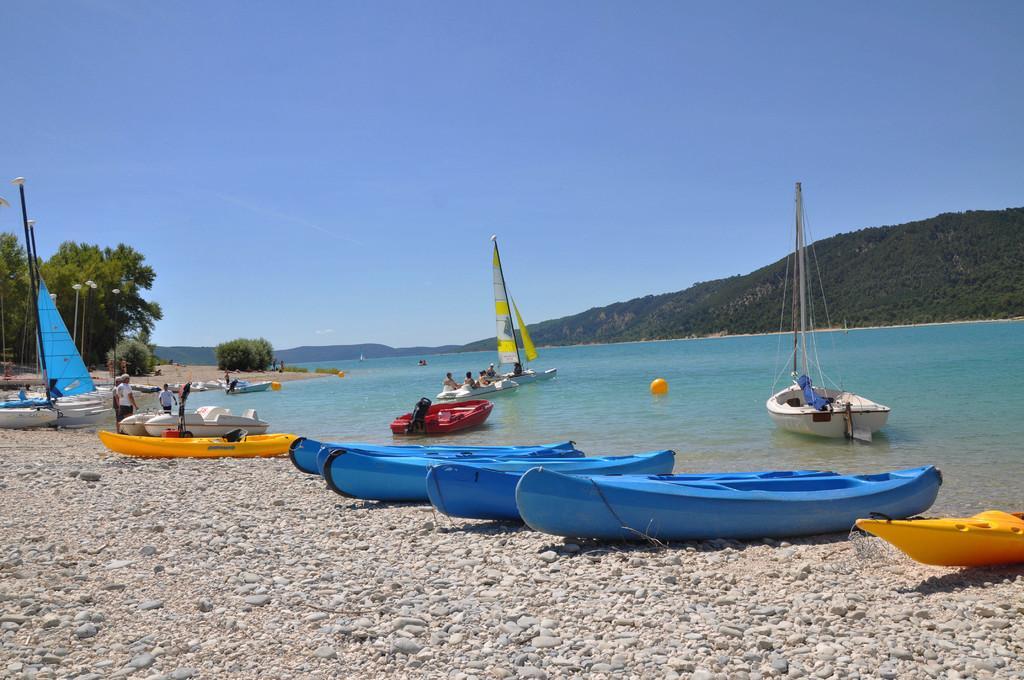Can you describe this image briefly? In this image I can see the ground, few small stones and number of boats. I can see few persons standing, the water, few boats on the water and few mountains. In the background I can see the sky. 